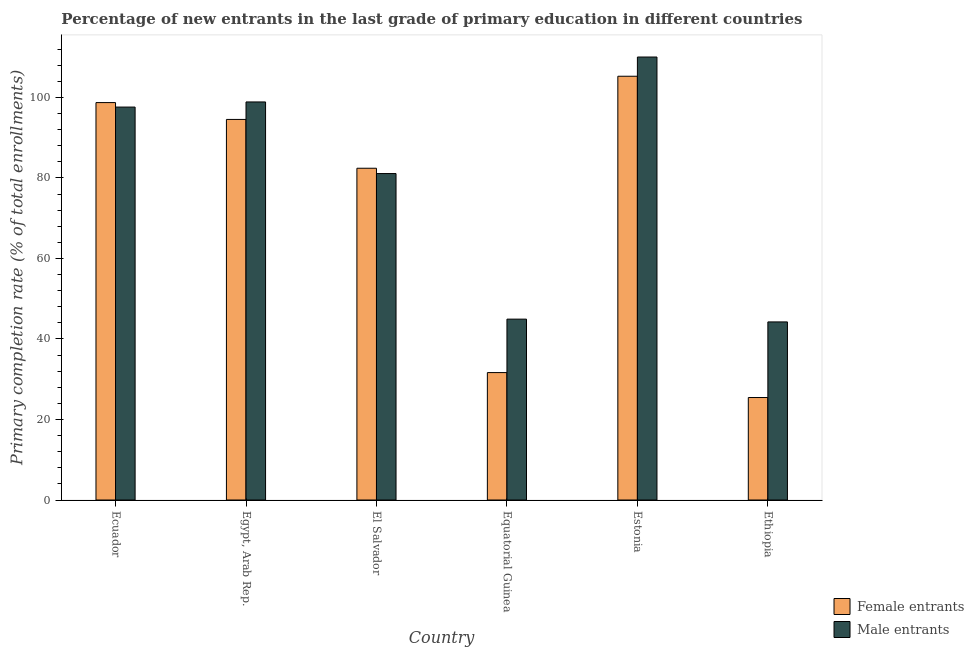How many different coloured bars are there?
Your answer should be very brief. 2. Are the number of bars per tick equal to the number of legend labels?
Provide a short and direct response. Yes. Are the number of bars on each tick of the X-axis equal?
Your answer should be very brief. Yes. How many bars are there on the 6th tick from the right?
Make the answer very short. 2. What is the label of the 6th group of bars from the left?
Provide a succinct answer. Ethiopia. In how many cases, is the number of bars for a given country not equal to the number of legend labels?
Your answer should be compact. 0. What is the primary completion rate of male entrants in El Salvador?
Offer a very short reply. 81.09. Across all countries, what is the maximum primary completion rate of female entrants?
Offer a very short reply. 105.27. Across all countries, what is the minimum primary completion rate of male entrants?
Provide a succinct answer. 44.24. In which country was the primary completion rate of male entrants maximum?
Keep it short and to the point. Estonia. In which country was the primary completion rate of male entrants minimum?
Your answer should be very brief. Ethiopia. What is the total primary completion rate of male entrants in the graph?
Make the answer very short. 476.81. What is the difference between the primary completion rate of female entrants in Ecuador and that in Ethiopia?
Ensure brevity in your answer.  73.27. What is the difference between the primary completion rate of male entrants in Ecuador and the primary completion rate of female entrants in El Salvador?
Your answer should be very brief. 15.2. What is the average primary completion rate of female entrants per country?
Your response must be concise. 73.01. What is the difference between the primary completion rate of male entrants and primary completion rate of female entrants in Equatorial Guinea?
Provide a succinct answer. 13.28. In how many countries, is the primary completion rate of male entrants greater than 48 %?
Your response must be concise. 4. What is the ratio of the primary completion rate of female entrants in Egypt, Arab Rep. to that in Estonia?
Offer a very short reply. 0.9. What is the difference between the highest and the second highest primary completion rate of female entrants?
Make the answer very short. 6.54. What is the difference between the highest and the lowest primary completion rate of male entrants?
Offer a very short reply. 65.8. In how many countries, is the primary completion rate of female entrants greater than the average primary completion rate of female entrants taken over all countries?
Ensure brevity in your answer.  4. Is the sum of the primary completion rate of male entrants in Ecuador and Estonia greater than the maximum primary completion rate of female entrants across all countries?
Keep it short and to the point. Yes. What does the 2nd bar from the left in Equatorial Guinea represents?
Keep it short and to the point. Male entrants. What does the 1st bar from the right in Estonia represents?
Provide a succinct answer. Male entrants. What is the difference between two consecutive major ticks on the Y-axis?
Provide a succinct answer. 20. Does the graph contain grids?
Provide a short and direct response. No. Where does the legend appear in the graph?
Your response must be concise. Bottom right. What is the title of the graph?
Provide a succinct answer. Percentage of new entrants in the last grade of primary education in different countries. Does "Fertility rate" appear as one of the legend labels in the graph?
Provide a short and direct response. No. What is the label or title of the X-axis?
Provide a short and direct response. Country. What is the label or title of the Y-axis?
Offer a terse response. Primary completion rate (% of total enrollments). What is the Primary completion rate (% of total enrollments) of Female entrants in Ecuador?
Your answer should be very brief. 98.73. What is the Primary completion rate (% of total enrollments) of Male entrants in Ecuador?
Your response must be concise. 97.61. What is the Primary completion rate (% of total enrollments) of Female entrants in Egypt, Arab Rep.?
Your answer should be compact. 94.54. What is the Primary completion rate (% of total enrollments) in Male entrants in Egypt, Arab Rep.?
Provide a succinct answer. 98.89. What is the Primary completion rate (% of total enrollments) in Female entrants in El Salvador?
Ensure brevity in your answer.  82.41. What is the Primary completion rate (% of total enrollments) of Male entrants in El Salvador?
Offer a very short reply. 81.09. What is the Primary completion rate (% of total enrollments) of Female entrants in Equatorial Guinea?
Offer a very short reply. 31.65. What is the Primary completion rate (% of total enrollments) in Male entrants in Equatorial Guinea?
Provide a succinct answer. 44.93. What is the Primary completion rate (% of total enrollments) of Female entrants in Estonia?
Make the answer very short. 105.27. What is the Primary completion rate (% of total enrollments) of Male entrants in Estonia?
Your response must be concise. 110.04. What is the Primary completion rate (% of total enrollments) in Female entrants in Ethiopia?
Keep it short and to the point. 25.46. What is the Primary completion rate (% of total enrollments) of Male entrants in Ethiopia?
Give a very brief answer. 44.24. Across all countries, what is the maximum Primary completion rate (% of total enrollments) in Female entrants?
Ensure brevity in your answer.  105.27. Across all countries, what is the maximum Primary completion rate (% of total enrollments) in Male entrants?
Your response must be concise. 110.04. Across all countries, what is the minimum Primary completion rate (% of total enrollments) in Female entrants?
Ensure brevity in your answer.  25.46. Across all countries, what is the minimum Primary completion rate (% of total enrollments) in Male entrants?
Give a very brief answer. 44.24. What is the total Primary completion rate (% of total enrollments) in Female entrants in the graph?
Provide a succinct answer. 438.06. What is the total Primary completion rate (% of total enrollments) in Male entrants in the graph?
Keep it short and to the point. 476.81. What is the difference between the Primary completion rate (% of total enrollments) in Female entrants in Ecuador and that in Egypt, Arab Rep.?
Your answer should be very brief. 4.19. What is the difference between the Primary completion rate (% of total enrollments) in Male entrants in Ecuador and that in Egypt, Arab Rep.?
Give a very brief answer. -1.28. What is the difference between the Primary completion rate (% of total enrollments) in Female entrants in Ecuador and that in El Salvador?
Ensure brevity in your answer.  16.31. What is the difference between the Primary completion rate (% of total enrollments) in Male entrants in Ecuador and that in El Salvador?
Make the answer very short. 16.52. What is the difference between the Primary completion rate (% of total enrollments) of Female entrants in Ecuador and that in Equatorial Guinea?
Make the answer very short. 67.07. What is the difference between the Primary completion rate (% of total enrollments) in Male entrants in Ecuador and that in Equatorial Guinea?
Your response must be concise. 52.68. What is the difference between the Primary completion rate (% of total enrollments) in Female entrants in Ecuador and that in Estonia?
Provide a short and direct response. -6.54. What is the difference between the Primary completion rate (% of total enrollments) of Male entrants in Ecuador and that in Estonia?
Ensure brevity in your answer.  -12.43. What is the difference between the Primary completion rate (% of total enrollments) of Female entrants in Ecuador and that in Ethiopia?
Provide a succinct answer. 73.27. What is the difference between the Primary completion rate (% of total enrollments) in Male entrants in Ecuador and that in Ethiopia?
Provide a short and direct response. 53.37. What is the difference between the Primary completion rate (% of total enrollments) in Female entrants in Egypt, Arab Rep. and that in El Salvador?
Provide a succinct answer. 12.13. What is the difference between the Primary completion rate (% of total enrollments) of Male entrants in Egypt, Arab Rep. and that in El Salvador?
Your response must be concise. 17.79. What is the difference between the Primary completion rate (% of total enrollments) of Female entrants in Egypt, Arab Rep. and that in Equatorial Guinea?
Your response must be concise. 62.89. What is the difference between the Primary completion rate (% of total enrollments) of Male entrants in Egypt, Arab Rep. and that in Equatorial Guinea?
Offer a terse response. 53.95. What is the difference between the Primary completion rate (% of total enrollments) in Female entrants in Egypt, Arab Rep. and that in Estonia?
Offer a very short reply. -10.73. What is the difference between the Primary completion rate (% of total enrollments) of Male entrants in Egypt, Arab Rep. and that in Estonia?
Keep it short and to the point. -11.16. What is the difference between the Primary completion rate (% of total enrollments) in Female entrants in Egypt, Arab Rep. and that in Ethiopia?
Make the answer very short. 69.08. What is the difference between the Primary completion rate (% of total enrollments) in Male entrants in Egypt, Arab Rep. and that in Ethiopia?
Ensure brevity in your answer.  54.65. What is the difference between the Primary completion rate (% of total enrollments) in Female entrants in El Salvador and that in Equatorial Guinea?
Your response must be concise. 50.76. What is the difference between the Primary completion rate (% of total enrollments) in Male entrants in El Salvador and that in Equatorial Guinea?
Your response must be concise. 36.16. What is the difference between the Primary completion rate (% of total enrollments) of Female entrants in El Salvador and that in Estonia?
Make the answer very short. -22.86. What is the difference between the Primary completion rate (% of total enrollments) of Male entrants in El Salvador and that in Estonia?
Offer a terse response. -28.95. What is the difference between the Primary completion rate (% of total enrollments) in Female entrants in El Salvador and that in Ethiopia?
Your answer should be very brief. 56.96. What is the difference between the Primary completion rate (% of total enrollments) in Male entrants in El Salvador and that in Ethiopia?
Your answer should be very brief. 36.85. What is the difference between the Primary completion rate (% of total enrollments) in Female entrants in Equatorial Guinea and that in Estonia?
Your response must be concise. -73.62. What is the difference between the Primary completion rate (% of total enrollments) of Male entrants in Equatorial Guinea and that in Estonia?
Give a very brief answer. -65.11. What is the difference between the Primary completion rate (% of total enrollments) in Female entrants in Equatorial Guinea and that in Ethiopia?
Your answer should be very brief. 6.19. What is the difference between the Primary completion rate (% of total enrollments) in Male entrants in Equatorial Guinea and that in Ethiopia?
Make the answer very short. 0.69. What is the difference between the Primary completion rate (% of total enrollments) of Female entrants in Estonia and that in Ethiopia?
Your answer should be compact. 79.81. What is the difference between the Primary completion rate (% of total enrollments) in Male entrants in Estonia and that in Ethiopia?
Offer a very short reply. 65.8. What is the difference between the Primary completion rate (% of total enrollments) in Female entrants in Ecuador and the Primary completion rate (% of total enrollments) in Male entrants in Egypt, Arab Rep.?
Ensure brevity in your answer.  -0.16. What is the difference between the Primary completion rate (% of total enrollments) of Female entrants in Ecuador and the Primary completion rate (% of total enrollments) of Male entrants in El Salvador?
Your answer should be very brief. 17.63. What is the difference between the Primary completion rate (% of total enrollments) in Female entrants in Ecuador and the Primary completion rate (% of total enrollments) in Male entrants in Equatorial Guinea?
Offer a very short reply. 53.79. What is the difference between the Primary completion rate (% of total enrollments) in Female entrants in Ecuador and the Primary completion rate (% of total enrollments) in Male entrants in Estonia?
Provide a succinct answer. -11.32. What is the difference between the Primary completion rate (% of total enrollments) in Female entrants in Ecuador and the Primary completion rate (% of total enrollments) in Male entrants in Ethiopia?
Your answer should be compact. 54.49. What is the difference between the Primary completion rate (% of total enrollments) in Female entrants in Egypt, Arab Rep. and the Primary completion rate (% of total enrollments) in Male entrants in El Salvador?
Your response must be concise. 13.45. What is the difference between the Primary completion rate (% of total enrollments) in Female entrants in Egypt, Arab Rep. and the Primary completion rate (% of total enrollments) in Male entrants in Equatorial Guinea?
Ensure brevity in your answer.  49.61. What is the difference between the Primary completion rate (% of total enrollments) in Female entrants in Egypt, Arab Rep. and the Primary completion rate (% of total enrollments) in Male entrants in Estonia?
Provide a short and direct response. -15.5. What is the difference between the Primary completion rate (% of total enrollments) in Female entrants in Egypt, Arab Rep. and the Primary completion rate (% of total enrollments) in Male entrants in Ethiopia?
Provide a succinct answer. 50.3. What is the difference between the Primary completion rate (% of total enrollments) in Female entrants in El Salvador and the Primary completion rate (% of total enrollments) in Male entrants in Equatorial Guinea?
Your answer should be compact. 37.48. What is the difference between the Primary completion rate (% of total enrollments) of Female entrants in El Salvador and the Primary completion rate (% of total enrollments) of Male entrants in Estonia?
Provide a short and direct response. -27.63. What is the difference between the Primary completion rate (% of total enrollments) in Female entrants in El Salvador and the Primary completion rate (% of total enrollments) in Male entrants in Ethiopia?
Your answer should be compact. 38.18. What is the difference between the Primary completion rate (% of total enrollments) in Female entrants in Equatorial Guinea and the Primary completion rate (% of total enrollments) in Male entrants in Estonia?
Offer a very short reply. -78.39. What is the difference between the Primary completion rate (% of total enrollments) of Female entrants in Equatorial Guinea and the Primary completion rate (% of total enrollments) of Male entrants in Ethiopia?
Make the answer very short. -12.59. What is the difference between the Primary completion rate (% of total enrollments) in Female entrants in Estonia and the Primary completion rate (% of total enrollments) in Male entrants in Ethiopia?
Your answer should be very brief. 61.03. What is the average Primary completion rate (% of total enrollments) in Female entrants per country?
Your answer should be very brief. 73.01. What is the average Primary completion rate (% of total enrollments) in Male entrants per country?
Give a very brief answer. 79.47. What is the difference between the Primary completion rate (% of total enrollments) of Female entrants and Primary completion rate (% of total enrollments) of Male entrants in Ecuador?
Your answer should be very brief. 1.12. What is the difference between the Primary completion rate (% of total enrollments) in Female entrants and Primary completion rate (% of total enrollments) in Male entrants in Egypt, Arab Rep.?
Make the answer very short. -4.35. What is the difference between the Primary completion rate (% of total enrollments) in Female entrants and Primary completion rate (% of total enrollments) in Male entrants in El Salvador?
Keep it short and to the point. 1.32. What is the difference between the Primary completion rate (% of total enrollments) in Female entrants and Primary completion rate (% of total enrollments) in Male entrants in Equatorial Guinea?
Make the answer very short. -13.28. What is the difference between the Primary completion rate (% of total enrollments) in Female entrants and Primary completion rate (% of total enrollments) in Male entrants in Estonia?
Make the answer very short. -4.77. What is the difference between the Primary completion rate (% of total enrollments) in Female entrants and Primary completion rate (% of total enrollments) in Male entrants in Ethiopia?
Your response must be concise. -18.78. What is the ratio of the Primary completion rate (% of total enrollments) in Female entrants in Ecuador to that in Egypt, Arab Rep.?
Provide a succinct answer. 1.04. What is the ratio of the Primary completion rate (% of total enrollments) of Male entrants in Ecuador to that in Egypt, Arab Rep.?
Keep it short and to the point. 0.99. What is the ratio of the Primary completion rate (% of total enrollments) in Female entrants in Ecuador to that in El Salvador?
Make the answer very short. 1.2. What is the ratio of the Primary completion rate (% of total enrollments) in Male entrants in Ecuador to that in El Salvador?
Your response must be concise. 1.2. What is the ratio of the Primary completion rate (% of total enrollments) in Female entrants in Ecuador to that in Equatorial Guinea?
Offer a very short reply. 3.12. What is the ratio of the Primary completion rate (% of total enrollments) of Male entrants in Ecuador to that in Equatorial Guinea?
Keep it short and to the point. 2.17. What is the ratio of the Primary completion rate (% of total enrollments) in Female entrants in Ecuador to that in Estonia?
Make the answer very short. 0.94. What is the ratio of the Primary completion rate (% of total enrollments) in Male entrants in Ecuador to that in Estonia?
Make the answer very short. 0.89. What is the ratio of the Primary completion rate (% of total enrollments) of Female entrants in Ecuador to that in Ethiopia?
Make the answer very short. 3.88. What is the ratio of the Primary completion rate (% of total enrollments) of Male entrants in Ecuador to that in Ethiopia?
Provide a short and direct response. 2.21. What is the ratio of the Primary completion rate (% of total enrollments) of Female entrants in Egypt, Arab Rep. to that in El Salvador?
Offer a terse response. 1.15. What is the ratio of the Primary completion rate (% of total enrollments) in Male entrants in Egypt, Arab Rep. to that in El Salvador?
Your answer should be very brief. 1.22. What is the ratio of the Primary completion rate (% of total enrollments) in Female entrants in Egypt, Arab Rep. to that in Equatorial Guinea?
Provide a succinct answer. 2.99. What is the ratio of the Primary completion rate (% of total enrollments) in Male entrants in Egypt, Arab Rep. to that in Equatorial Guinea?
Keep it short and to the point. 2.2. What is the ratio of the Primary completion rate (% of total enrollments) in Female entrants in Egypt, Arab Rep. to that in Estonia?
Offer a very short reply. 0.9. What is the ratio of the Primary completion rate (% of total enrollments) in Male entrants in Egypt, Arab Rep. to that in Estonia?
Give a very brief answer. 0.9. What is the ratio of the Primary completion rate (% of total enrollments) in Female entrants in Egypt, Arab Rep. to that in Ethiopia?
Give a very brief answer. 3.71. What is the ratio of the Primary completion rate (% of total enrollments) in Male entrants in Egypt, Arab Rep. to that in Ethiopia?
Ensure brevity in your answer.  2.24. What is the ratio of the Primary completion rate (% of total enrollments) of Female entrants in El Salvador to that in Equatorial Guinea?
Make the answer very short. 2.6. What is the ratio of the Primary completion rate (% of total enrollments) in Male entrants in El Salvador to that in Equatorial Guinea?
Give a very brief answer. 1.8. What is the ratio of the Primary completion rate (% of total enrollments) in Female entrants in El Salvador to that in Estonia?
Ensure brevity in your answer.  0.78. What is the ratio of the Primary completion rate (% of total enrollments) in Male entrants in El Salvador to that in Estonia?
Ensure brevity in your answer.  0.74. What is the ratio of the Primary completion rate (% of total enrollments) in Female entrants in El Salvador to that in Ethiopia?
Your response must be concise. 3.24. What is the ratio of the Primary completion rate (% of total enrollments) in Male entrants in El Salvador to that in Ethiopia?
Give a very brief answer. 1.83. What is the ratio of the Primary completion rate (% of total enrollments) in Female entrants in Equatorial Guinea to that in Estonia?
Provide a short and direct response. 0.3. What is the ratio of the Primary completion rate (% of total enrollments) of Male entrants in Equatorial Guinea to that in Estonia?
Your answer should be compact. 0.41. What is the ratio of the Primary completion rate (% of total enrollments) in Female entrants in Equatorial Guinea to that in Ethiopia?
Give a very brief answer. 1.24. What is the ratio of the Primary completion rate (% of total enrollments) in Male entrants in Equatorial Guinea to that in Ethiopia?
Your answer should be very brief. 1.02. What is the ratio of the Primary completion rate (% of total enrollments) in Female entrants in Estonia to that in Ethiopia?
Keep it short and to the point. 4.14. What is the ratio of the Primary completion rate (% of total enrollments) in Male entrants in Estonia to that in Ethiopia?
Your answer should be very brief. 2.49. What is the difference between the highest and the second highest Primary completion rate (% of total enrollments) in Female entrants?
Keep it short and to the point. 6.54. What is the difference between the highest and the second highest Primary completion rate (% of total enrollments) in Male entrants?
Make the answer very short. 11.16. What is the difference between the highest and the lowest Primary completion rate (% of total enrollments) of Female entrants?
Offer a terse response. 79.81. What is the difference between the highest and the lowest Primary completion rate (% of total enrollments) in Male entrants?
Give a very brief answer. 65.8. 